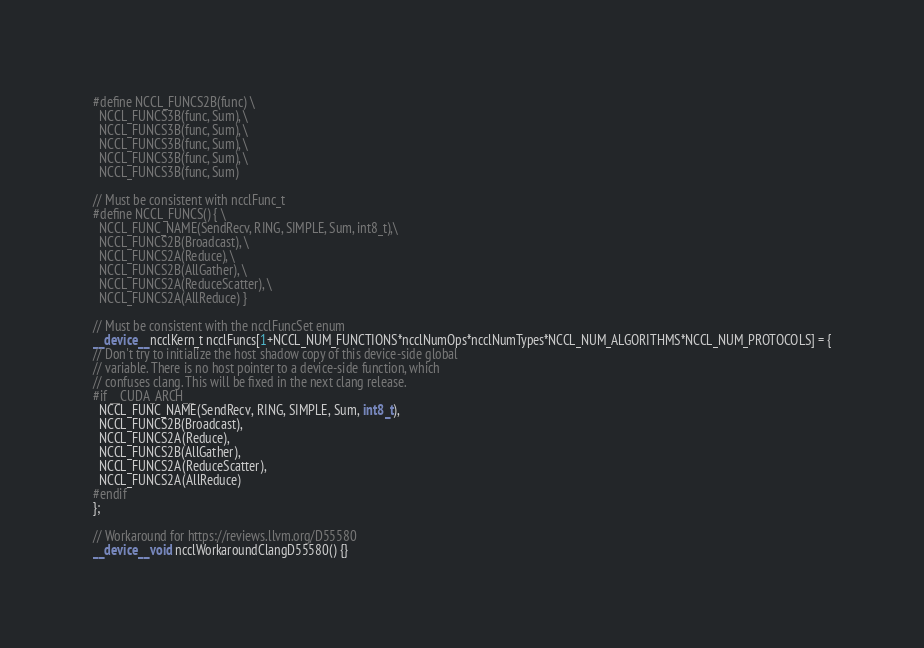<code> <loc_0><loc_0><loc_500><loc_500><_Cuda_>#define NCCL_FUNCS2B(func) \
  NCCL_FUNCS3B(func, Sum), \
  NCCL_FUNCS3B(func, Sum), \
  NCCL_FUNCS3B(func, Sum), \
  NCCL_FUNCS3B(func, Sum), \
  NCCL_FUNCS3B(func, Sum)

// Must be consistent with ncclFunc_t
#define NCCL_FUNCS() { \
  NCCL_FUNC_NAME(SendRecv, RING, SIMPLE, Sum, int8_t),\
  NCCL_FUNCS2B(Broadcast), \
  NCCL_FUNCS2A(Reduce), \
  NCCL_FUNCS2B(AllGather), \
  NCCL_FUNCS2A(ReduceScatter), \
  NCCL_FUNCS2A(AllReduce) }

// Must be consistent with the ncclFuncSet enum
__device__ ncclKern_t ncclFuncs[1+NCCL_NUM_FUNCTIONS*ncclNumOps*ncclNumTypes*NCCL_NUM_ALGORITHMS*NCCL_NUM_PROTOCOLS] = {
// Don't try to initialize the host shadow copy of this device-side global
// variable. There is no host pointer to a device-side function, which
// confuses clang. This will be fixed in the next clang release.
#if __CUDA_ARCH__
  NCCL_FUNC_NAME(SendRecv, RING, SIMPLE, Sum, int8_t),
  NCCL_FUNCS2B(Broadcast),
  NCCL_FUNCS2A(Reduce),
  NCCL_FUNCS2B(AllGather),
  NCCL_FUNCS2A(ReduceScatter),
  NCCL_FUNCS2A(AllReduce)
#endif
};

// Workaround for https://reviews.llvm.org/D55580
__device__ void ncclWorkaroundClangD55580() {}
</code> 